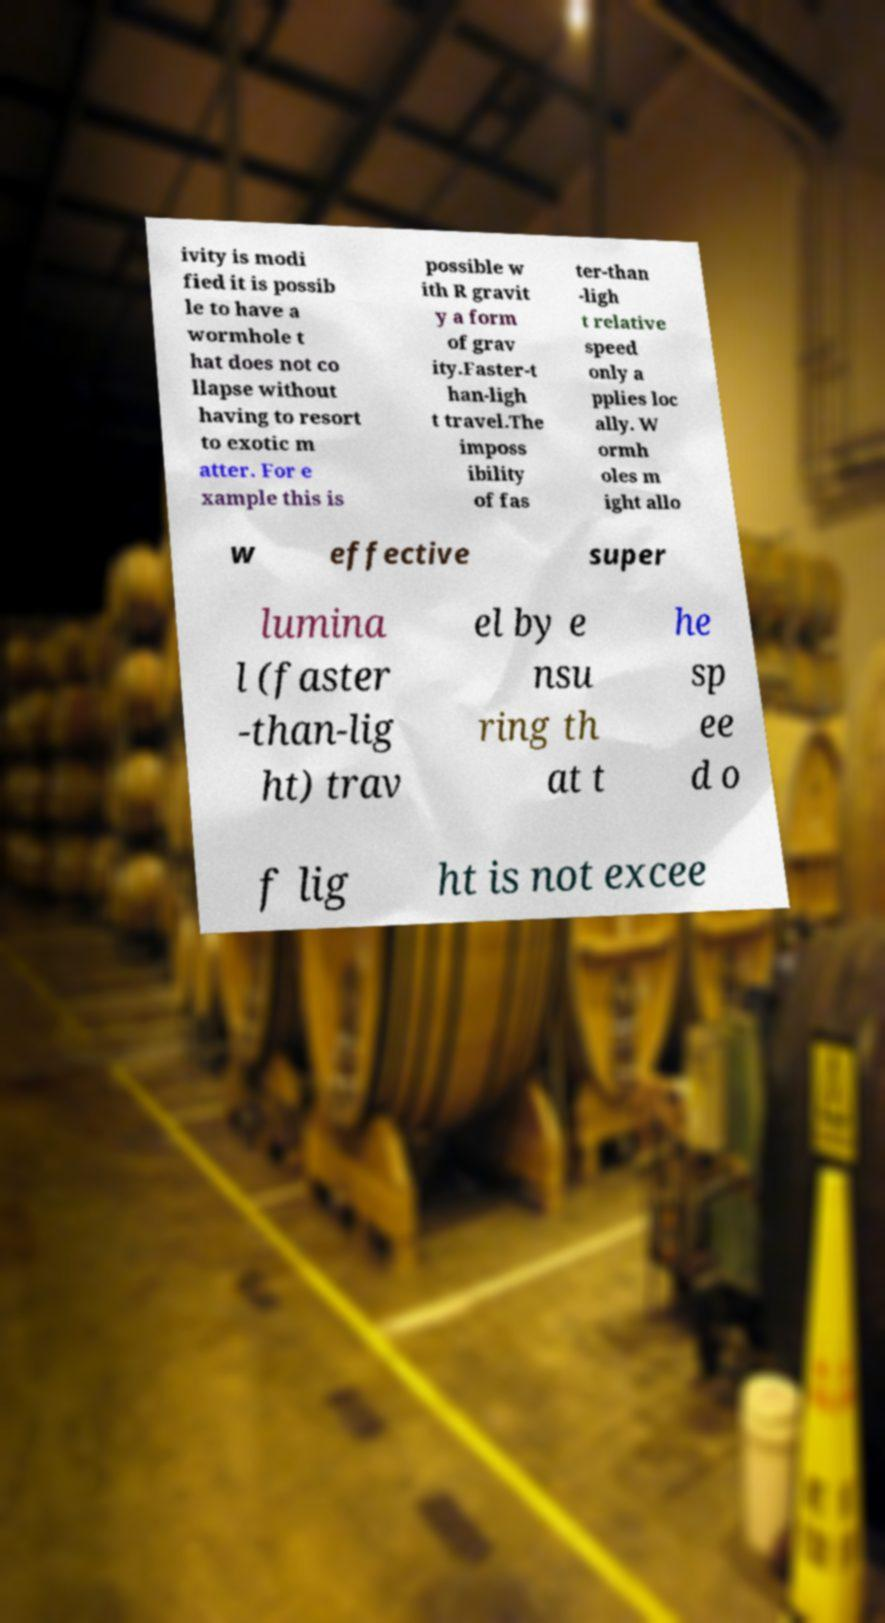I need the written content from this picture converted into text. Can you do that? ivity is modi fied it is possib le to have a wormhole t hat does not co llapse without having to resort to exotic m atter. For e xample this is possible w ith R gravit y a form of grav ity.Faster-t han-ligh t travel.The imposs ibility of fas ter-than -ligh t relative speed only a pplies loc ally. W ormh oles m ight allo w effective super lumina l (faster -than-lig ht) trav el by e nsu ring th at t he sp ee d o f lig ht is not excee 